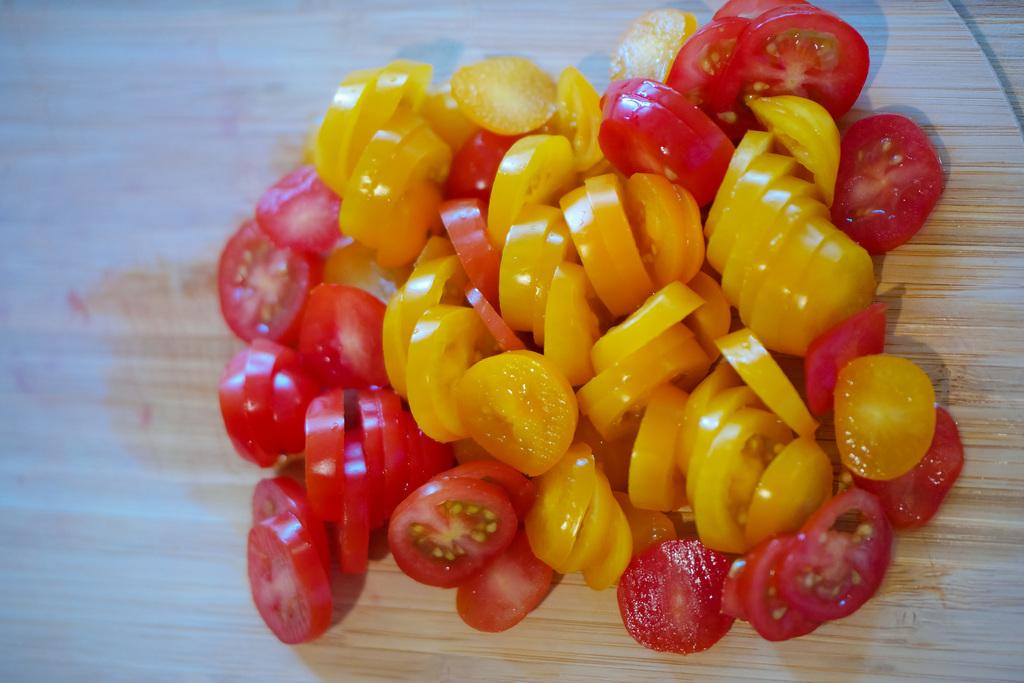What type of fruit is present in the image? There are tomatoes in the image. What colors can be seen among the tomatoes? The tomatoes are in red and yellow colors. On what surface are the tomatoes placed? The tomatoes are kept on a chopping board. Is there a woman smashing the tomatoes with an insect in the image? No, there is no woman, smashing, or insect present in the image. The image only shows tomatoes on a chopping board. 